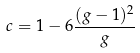<formula> <loc_0><loc_0><loc_500><loc_500>c = 1 - 6 \frac { ( g - 1 ) ^ { 2 } } { g }</formula> 